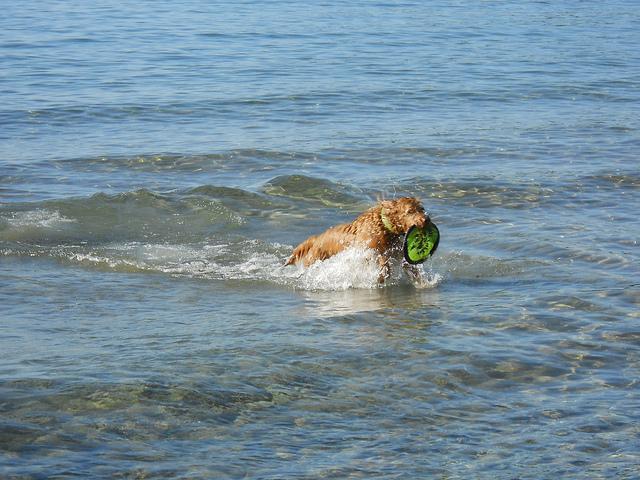How many dogs are in the picture?
Give a very brief answer. 1. 